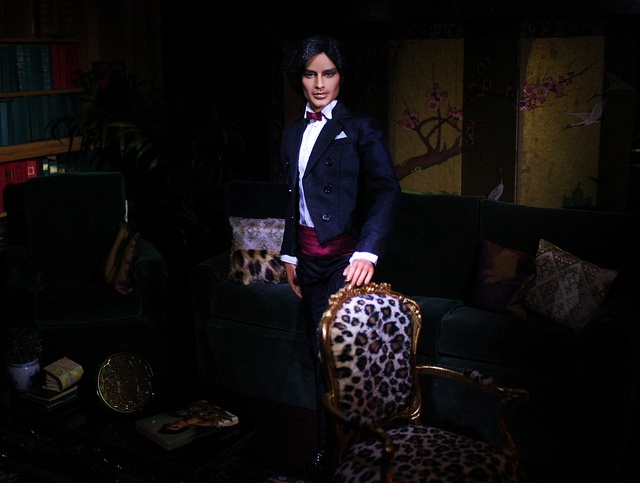Describe the objects in this image and their specific colors. I can see couch in black, gray, and purple tones, chair in black, gray, maroon, and lavender tones, people in black, lavender, navy, and maroon tones, chair in black and gray tones, and chair in black, gray, maroon, and purple tones in this image. 